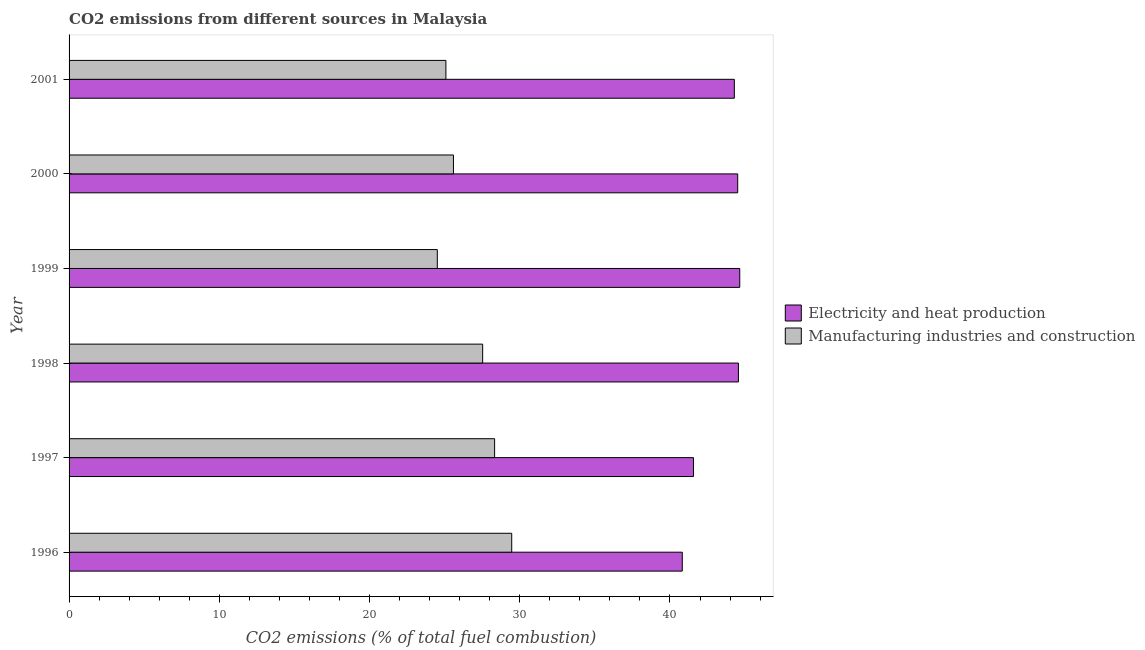How many groups of bars are there?
Your answer should be very brief. 6. Are the number of bars per tick equal to the number of legend labels?
Provide a short and direct response. Yes. What is the co2 emissions due to electricity and heat production in 1996?
Keep it short and to the point. 40.82. Across all years, what is the maximum co2 emissions due to manufacturing industries?
Your answer should be compact. 29.47. Across all years, what is the minimum co2 emissions due to electricity and heat production?
Your response must be concise. 40.82. In which year was the co2 emissions due to electricity and heat production maximum?
Offer a very short reply. 1999. What is the total co2 emissions due to electricity and heat production in the graph?
Provide a short and direct response. 260.38. What is the difference between the co2 emissions due to electricity and heat production in 1999 and that in 2001?
Your response must be concise. 0.36. What is the difference between the co2 emissions due to electricity and heat production in 2001 and the co2 emissions due to manufacturing industries in 1996?
Ensure brevity in your answer.  14.82. What is the average co2 emissions due to manufacturing industries per year?
Your response must be concise. 26.75. In the year 1998, what is the difference between the co2 emissions due to electricity and heat production and co2 emissions due to manufacturing industries?
Provide a short and direct response. 17.03. In how many years, is the co2 emissions due to manufacturing industries greater than 2 %?
Ensure brevity in your answer.  6. What is the ratio of the co2 emissions due to electricity and heat production in 1996 to that in 1998?
Your answer should be compact. 0.92. Is the difference between the co2 emissions due to manufacturing industries in 1998 and 1999 greater than the difference between the co2 emissions due to electricity and heat production in 1998 and 1999?
Ensure brevity in your answer.  Yes. What is the difference between the highest and the second highest co2 emissions due to electricity and heat production?
Offer a terse response. 0.09. What is the difference between the highest and the lowest co2 emissions due to manufacturing industries?
Keep it short and to the point. 4.95. In how many years, is the co2 emissions due to manufacturing industries greater than the average co2 emissions due to manufacturing industries taken over all years?
Your response must be concise. 3. Is the sum of the co2 emissions due to manufacturing industries in 1998 and 2000 greater than the maximum co2 emissions due to electricity and heat production across all years?
Your answer should be compact. Yes. What does the 1st bar from the top in 1996 represents?
Provide a short and direct response. Manufacturing industries and construction. What does the 1st bar from the bottom in 1997 represents?
Provide a succinct answer. Electricity and heat production. Are all the bars in the graph horizontal?
Your answer should be very brief. Yes. How many years are there in the graph?
Provide a short and direct response. 6. What is the difference between two consecutive major ticks on the X-axis?
Provide a succinct answer. 10. Are the values on the major ticks of X-axis written in scientific E-notation?
Provide a short and direct response. No. Where does the legend appear in the graph?
Your response must be concise. Center right. What is the title of the graph?
Offer a very short reply. CO2 emissions from different sources in Malaysia. What is the label or title of the X-axis?
Keep it short and to the point. CO2 emissions (% of total fuel combustion). What is the CO2 emissions (% of total fuel combustion) in Electricity and heat production in 1996?
Give a very brief answer. 40.82. What is the CO2 emissions (% of total fuel combustion) in Manufacturing industries and construction in 1996?
Your response must be concise. 29.47. What is the CO2 emissions (% of total fuel combustion) in Electricity and heat production in 1997?
Your answer should be compact. 41.57. What is the CO2 emissions (% of total fuel combustion) in Manufacturing industries and construction in 1997?
Give a very brief answer. 28.33. What is the CO2 emissions (% of total fuel combustion) of Electricity and heat production in 1998?
Provide a succinct answer. 44.56. What is the CO2 emissions (% of total fuel combustion) in Manufacturing industries and construction in 1998?
Your answer should be compact. 27.53. What is the CO2 emissions (% of total fuel combustion) of Electricity and heat production in 1999?
Offer a terse response. 44.65. What is the CO2 emissions (% of total fuel combustion) in Manufacturing industries and construction in 1999?
Offer a very short reply. 24.51. What is the CO2 emissions (% of total fuel combustion) of Electricity and heat production in 2000?
Your answer should be compact. 44.51. What is the CO2 emissions (% of total fuel combustion) in Manufacturing industries and construction in 2000?
Your answer should be compact. 25.59. What is the CO2 emissions (% of total fuel combustion) in Electricity and heat production in 2001?
Your answer should be compact. 44.28. What is the CO2 emissions (% of total fuel combustion) in Manufacturing industries and construction in 2001?
Provide a short and direct response. 25.09. Across all years, what is the maximum CO2 emissions (% of total fuel combustion) in Electricity and heat production?
Ensure brevity in your answer.  44.65. Across all years, what is the maximum CO2 emissions (% of total fuel combustion) in Manufacturing industries and construction?
Your response must be concise. 29.47. Across all years, what is the minimum CO2 emissions (% of total fuel combustion) of Electricity and heat production?
Your response must be concise. 40.82. Across all years, what is the minimum CO2 emissions (% of total fuel combustion) of Manufacturing industries and construction?
Offer a terse response. 24.51. What is the total CO2 emissions (% of total fuel combustion) of Electricity and heat production in the graph?
Offer a terse response. 260.38. What is the total CO2 emissions (% of total fuel combustion) in Manufacturing industries and construction in the graph?
Make the answer very short. 160.51. What is the difference between the CO2 emissions (% of total fuel combustion) in Electricity and heat production in 1996 and that in 1997?
Provide a succinct answer. -0.75. What is the difference between the CO2 emissions (% of total fuel combustion) of Manufacturing industries and construction in 1996 and that in 1997?
Provide a succinct answer. 1.14. What is the difference between the CO2 emissions (% of total fuel combustion) in Electricity and heat production in 1996 and that in 1998?
Your answer should be very brief. -3.74. What is the difference between the CO2 emissions (% of total fuel combustion) of Manufacturing industries and construction in 1996 and that in 1998?
Your answer should be very brief. 1.94. What is the difference between the CO2 emissions (% of total fuel combustion) of Electricity and heat production in 1996 and that in 1999?
Offer a terse response. -3.83. What is the difference between the CO2 emissions (% of total fuel combustion) of Manufacturing industries and construction in 1996 and that in 1999?
Offer a very short reply. 4.95. What is the difference between the CO2 emissions (% of total fuel combustion) of Electricity and heat production in 1996 and that in 2000?
Offer a terse response. -3.69. What is the difference between the CO2 emissions (% of total fuel combustion) in Manufacturing industries and construction in 1996 and that in 2000?
Provide a succinct answer. 3.88. What is the difference between the CO2 emissions (% of total fuel combustion) of Electricity and heat production in 1996 and that in 2001?
Your answer should be very brief. -3.46. What is the difference between the CO2 emissions (% of total fuel combustion) in Manufacturing industries and construction in 1996 and that in 2001?
Your response must be concise. 4.38. What is the difference between the CO2 emissions (% of total fuel combustion) of Electricity and heat production in 1997 and that in 1998?
Provide a short and direct response. -2.99. What is the difference between the CO2 emissions (% of total fuel combustion) of Manufacturing industries and construction in 1997 and that in 1998?
Ensure brevity in your answer.  0.8. What is the difference between the CO2 emissions (% of total fuel combustion) in Electricity and heat production in 1997 and that in 1999?
Your answer should be very brief. -3.08. What is the difference between the CO2 emissions (% of total fuel combustion) in Manufacturing industries and construction in 1997 and that in 1999?
Ensure brevity in your answer.  3.81. What is the difference between the CO2 emissions (% of total fuel combustion) in Electricity and heat production in 1997 and that in 2000?
Offer a terse response. -2.94. What is the difference between the CO2 emissions (% of total fuel combustion) of Manufacturing industries and construction in 1997 and that in 2000?
Provide a short and direct response. 2.74. What is the difference between the CO2 emissions (% of total fuel combustion) of Electricity and heat production in 1997 and that in 2001?
Your answer should be very brief. -2.72. What is the difference between the CO2 emissions (% of total fuel combustion) in Manufacturing industries and construction in 1997 and that in 2001?
Make the answer very short. 3.24. What is the difference between the CO2 emissions (% of total fuel combustion) in Electricity and heat production in 1998 and that in 1999?
Offer a very short reply. -0.09. What is the difference between the CO2 emissions (% of total fuel combustion) of Manufacturing industries and construction in 1998 and that in 1999?
Your answer should be compact. 3.02. What is the difference between the CO2 emissions (% of total fuel combustion) in Electricity and heat production in 1998 and that in 2000?
Make the answer very short. 0.05. What is the difference between the CO2 emissions (% of total fuel combustion) in Manufacturing industries and construction in 1998 and that in 2000?
Offer a very short reply. 1.94. What is the difference between the CO2 emissions (% of total fuel combustion) in Electricity and heat production in 1998 and that in 2001?
Provide a short and direct response. 0.27. What is the difference between the CO2 emissions (% of total fuel combustion) of Manufacturing industries and construction in 1998 and that in 2001?
Keep it short and to the point. 2.45. What is the difference between the CO2 emissions (% of total fuel combustion) of Electricity and heat production in 1999 and that in 2000?
Your answer should be very brief. 0.14. What is the difference between the CO2 emissions (% of total fuel combustion) of Manufacturing industries and construction in 1999 and that in 2000?
Offer a terse response. -1.07. What is the difference between the CO2 emissions (% of total fuel combustion) of Electricity and heat production in 1999 and that in 2001?
Make the answer very short. 0.36. What is the difference between the CO2 emissions (% of total fuel combustion) of Manufacturing industries and construction in 1999 and that in 2001?
Give a very brief answer. -0.57. What is the difference between the CO2 emissions (% of total fuel combustion) in Electricity and heat production in 2000 and that in 2001?
Provide a short and direct response. 0.22. What is the difference between the CO2 emissions (% of total fuel combustion) of Manufacturing industries and construction in 2000 and that in 2001?
Keep it short and to the point. 0.5. What is the difference between the CO2 emissions (% of total fuel combustion) in Electricity and heat production in 1996 and the CO2 emissions (% of total fuel combustion) in Manufacturing industries and construction in 1997?
Keep it short and to the point. 12.49. What is the difference between the CO2 emissions (% of total fuel combustion) in Electricity and heat production in 1996 and the CO2 emissions (% of total fuel combustion) in Manufacturing industries and construction in 1998?
Ensure brevity in your answer.  13.29. What is the difference between the CO2 emissions (% of total fuel combustion) of Electricity and heat production in 1996 and the CO2 emissions (% of total fuel combustion) of Manufacturing industries and construction in 1999?
Provide a short and direct response. 16.31. What is the difference between the CO2 emissions (% of total fuel combustion) of Electricity and heat production in 1996 and the CO2 emissions (% of total fuel combustion) of Manufacturing industries and construction in 2000?
Ensure brevity in your answer.  15.23. What is the difference between the CO2 emissions (% of total fuel combustion) of Electricity and heat production in 1996 and the CO2 emissions (% of total fuel combustion) of Manufacturing industries and construction in 2001?
Offer a very short reply. 15.74. What is the difference between the CO2 emissions (% of total fuel combustion) of Electricity and heat production in 1997 and the CO2 emissions (% of total fuel combustion) of Manufacturing industries and construction in 1998?
Make the answer very short. 14.03. What is the difference between the CO2 emissions (% of total fuel combustion) of Electricity and heat production in 1997 and the CO2 emissions (% of total fuel combustion) of Manufacturing industries and construction in 1999?
Ensure brevity in your answer.  17.05. What is the difference between the CO2 emissions (% of total fuel combustion) in Electricity and heat production in 1997 and the CO2 emissions (% of total fuel combustion) in Manufacturing industries and construction in 2000?
Your answer should be compact. 15.98. What is the difference between the CO2 emissions (% of total fuel combustion) of Electricity and heat production in 1997 and the CO2 emissions (% of total fuel combustion) of Manufacturing industries and construction in 2001?
Provide a succinct answer. 16.48. What is the difference between the CO2 emissions (% of total fuel combustion) in Electricity and heat production in 1998 and the CO2 emissions (% of total fuel combustion) in Manufacturing industries and construction in 1999?
Make the answer very short. 20.04. What is the difference between the CO2 emissions (% of total fuel combustion) of Electricity and heat production in 1998 and the CO2 emissions (% of total fuel combustion) of Manufacturing industries and construction in 2000?
Give a very brief answer. 18.97. What is the difference between the CO2 emissions (% of total fuel combustion) in Electricity and heat production in 1998 and the CO2 emissions (% of total fuel combustion) in Manufacturing industries and construction in 2001?
Offer a terse response. 19.47. What is the difference between the CO2 emissions (% of total fuel combustion) of Electricity and heat production in 1999 and the CO2 emissions (% of total fuel combustion) of Manufacturing industries and construction in 2000?
Provide a succinct answer. 19.06. What is the difference between the CO2 emissions (% of total fuel combustion) in Electricity and heat production in 1999 and the CO2 emissions (% of total fuel combustion) in Manufacturing industries and construction in 2001?
Your answer should be compact. 19.56. What is the difference between the CO2 emissions (% of total fuel combustion) of Electricity and heat production in 2000 and the CO2 emissions (% of total fuel combustion) of Manufacturing industries and construction in 2001?
Give a very brief answer. 19.42. What is the average CO2 emissions (% of total fuel combustion) in Electricity and heat production per year?
Make the answer very short. 43.4. What is the average CO2 emissions (% of total fuel combustion) in Manufacturing industries and construction per year?
Your response must be concise. 26.75. In the year 1996, what is the difference between the CO2 emissions (% of total fuel combustion) in Electricity and heat production and CO2 emissions (% of total fuel combustion) in Manufacturing industries and construction?
Provide a short and direct response. 11.35. In the year 1997, what is the difference between the CO2 emissions (% of total fuel combustion) of Electricity and heat production and CO2 emissions (% of total fuel combustion) of Manufacturing industries and construction?
Your response must be concise. 13.24. In the year 1998, what is the difference between the CO2 emissions (% of total fuel combustion) of Electricity and heat production and CO2 emissions (% of total fuel combustion) of Manufacturing industries and construction?
Your response must be concise. 17.03. In the year 1999, what is the difference between the CO2 emissions (% of total fuel combustion) in Electricity and heat production and CO2 emissions (% of total fuel combustion) in Manufacturing industries and construction?
Offer a very short reply. 20.13. In the year 2000, what is the difference between the CO2 emissions (% of total fuel combustion) in Electricity and heat production and CO2 emissions (% of total fuel combustion) in Manufacturing industries and construction?
Your answer should be very brief. 18.92. In the year 2001, what is the difference between the CO2 emissions (% of total fuel combustion) in Electricity and heat production and CO2 emissions (% of total fuel combustion) in Manufacturing industries and construction?
Offer a very short reply. 19.2. What is the ratio of the CO2 emissions (% of total fuel combustion) of Electricity and heat production in 1996 to that in 1997?
Provide a short and direct response. 0.98. What is the ratio of the CO2 emissions (% of total fuel combustion) of Manufacturing industries and construction in 1996 to that in 1997?
Your response must be concise. 1.04. What is the ratio of the CO2 emissions (% of total fuel combustion) in Electricity and heat production in 1996 to that in 1998?
Your response must be concise. 0.92. What is the ratio of the CO2 emissions (% of total fuel combustion) in Manufacturing industries and construction in 1996 to that in 1998?
Your response must be concise. 1.07. What is the ratio of the CO2 emissions (% of total fuel combustion) of Electricity and heat production in 1996 to that in 1999?
Your answer should be compact. 0.91. What is the ratio of the CO2 emissions (% of total fuel combustion) in Manufacturing industries and construction in 1996 to that in 1999?
Ensure brevity in your answer.  1.2. What is the ratio of the CO2 emissions (% of total fuel combustion) of Electricity and heat production in 1996 to that in 2000?
Ensure brevity in your answer.  0.92. What is the ratio of the CO2 emissions (% of total fuel combustion) of Manufacturing industries and construction in 1996 to that in 2000?
Keep it short and to the point. 1.15. What is the ratio of the CO2 emissions (% of total fuel combustion) in Electricity and heat production in 1996 to that in 2001?
Make the answer very short. 0.92. What is the ratio of the CO2 emissions (% of total fuel combustion) of Manufacturing industries and construction in 1996 to that in 2001?
Ensure brevity in your answer.  1.17. What is the ratio of the CO2 emissions (% of total fuel combustion) of Electricity and heat production in 1997 to that in 1998?
Make the answer very short. 0.93. What is the ratio of the CO2 emissions (% of total fuel combustion) in Manufacturing industries and construction in 1997 to that in 1998?
Offer a terse response. 1.03. What is the ratio of the CO2 emissions (% of total fuel combustion) in Electricity and heat production in 1997 to that in 1999?
Give a very brief answer. 0.93. What is the ratio of the CO2 emissions (% of total fuel combustion) of Manufacturing industries and construction in 1997 to that in 1999?
Provide a short and direct response. 1.16. What is the ratio of the CO2 emissions (% of total fuel combustion) in Electricity and heat production in 1997 to that in 2000?
Your answer should be very brief. 0.93. What is the ratio of the CO2 emissions (% of total fuel combustion) of Manufacturing industries and construction in 1997 to that in 2000?
Your response must be concise. 1.11. What is the ratio of the CO2 emissions (% of total fuel combustion) in Electricity and heat production in 1997 to that in 2001?
Provide a short and direct response. 0.94. What is the ratio of the CO2 emissions (% of total fuel combustion) of Manufacturing industries and construction in 1997 to that in 2001?
Ensure brevity in your answer.  1.13. What is the ratio of the CO2 emissions (% of total fuel combustion) of Manufacturing industries and construction in 1998 to that in 1999?
Your answer should be very brief. 1.12. What is the ratio of the CO2 emissions (% of total fuel combustion) of Manufacturing industries and construction in 1998 to that in 2000?
Offer a very short reply. 1.08. What is the ratio of the CO2 emissions (% of total fuel combustion) in Electricity and heat production in 1998 to that in 2001?
Ensure brevity in your answer.  1.01. What is the ratio of the CO2 emissions (% of total fuel combustion) of Manufacturing industries and construction in 1998 to that in 2001?
Give a very brief answer. 1.1. What is the ratio of the CO2 emissions (% of total fuel combustion) of Manufacturing industries and construction in 1999 to that in 2000?
Give a very brief answer. 0.96. What is the ratio of the CO2 emissions (% of total fuel combustion) of Electricity and heat production in 1999 to that in 2001?
Ensure brevity in your answer.  1.01. What is the ratio of the CO2 emissions (% of total fuel combustion) of Manufacturing industries and construction in 1999 to that in 2001?
Ensure brevity in your answer.  0.98. What is the difference between the highest and the second highest CO2 emissions (% of total fuel combustion) in Electricity and heat production?
Offer a very short reply. 0.09. What is the difference between the highest and the second highest CO2 emissions (% of total fuel combustion) of Manufacturing industries and construction?
Your answer should be very brief. 1.14. What is the difference between the highest and the lowest CO2 emissions (% of total fuel combustion) in Electricity and heat production?
Make the answer very short. 3.83. What is the difference between the highest and the lowest CO2 emissions (% of total fuel combustion) of Manufacturing industries and construction?
Give a very brief answer. 4.95. 